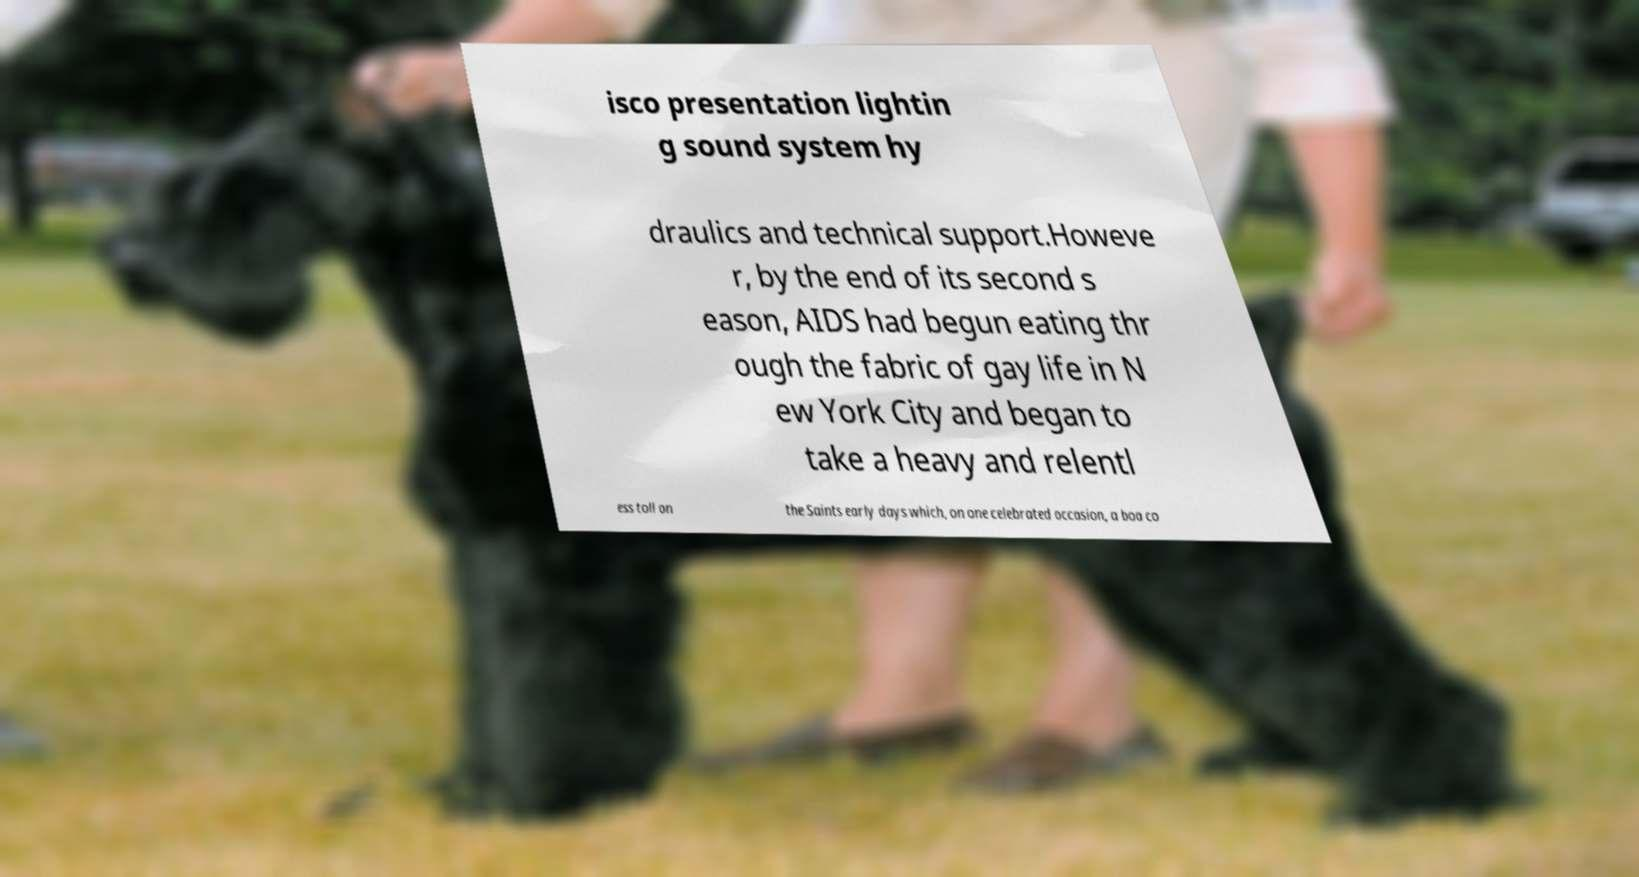Can you accurately transcribe the text from the provided image for me? isco presentation lightin g sound system hy draulics and technical support.Howeve r, by the end of its second s eason, AIDS had begun eating thr ough the fabric of gay life in N ew York City and began to take a heavy and relentl ess toll on the Saints early days which, on one celebrated occasion, a boa co 